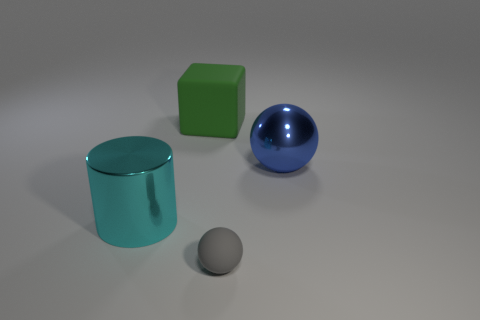How big is the matte thing that is left of the rubber thing that is in front of the matte cube?
Offer a terse response. Large. What shape is the big green matte object?
Your response must be concise. Cube. How many large things are either metal objects or blue objects?
Your response must be concise. 2. There is another object that is the same shape as the blue shiny thing; what is its size?
Provide a succinct answer. Small. What number of big shiny things are right of the green cube and to the left of the tiny matte thing?
Offer a terse response. 0. Do the big green thing and the metal thing that is to the right of the green cube have the same shape?
Make the answer very short. No. Is the number of blue shiny spheres that are on the left side of the green rubber block greater than the number of large brown metal things?
Provide a succinct answer. No. Is the number of blue shiny objects in front of the gray rubber object less than the number of small gray objects?
Your answer should be compact. Yes. There is a big thing that is both in front of the cube and on the left side of the blue metallic sphere; what is its material?
Your response must be concise. Metal. There is a sphere to the right of the small gray object; does it have the same color as the ball in front of the large cyan thing?
Your response must be concise. No. 